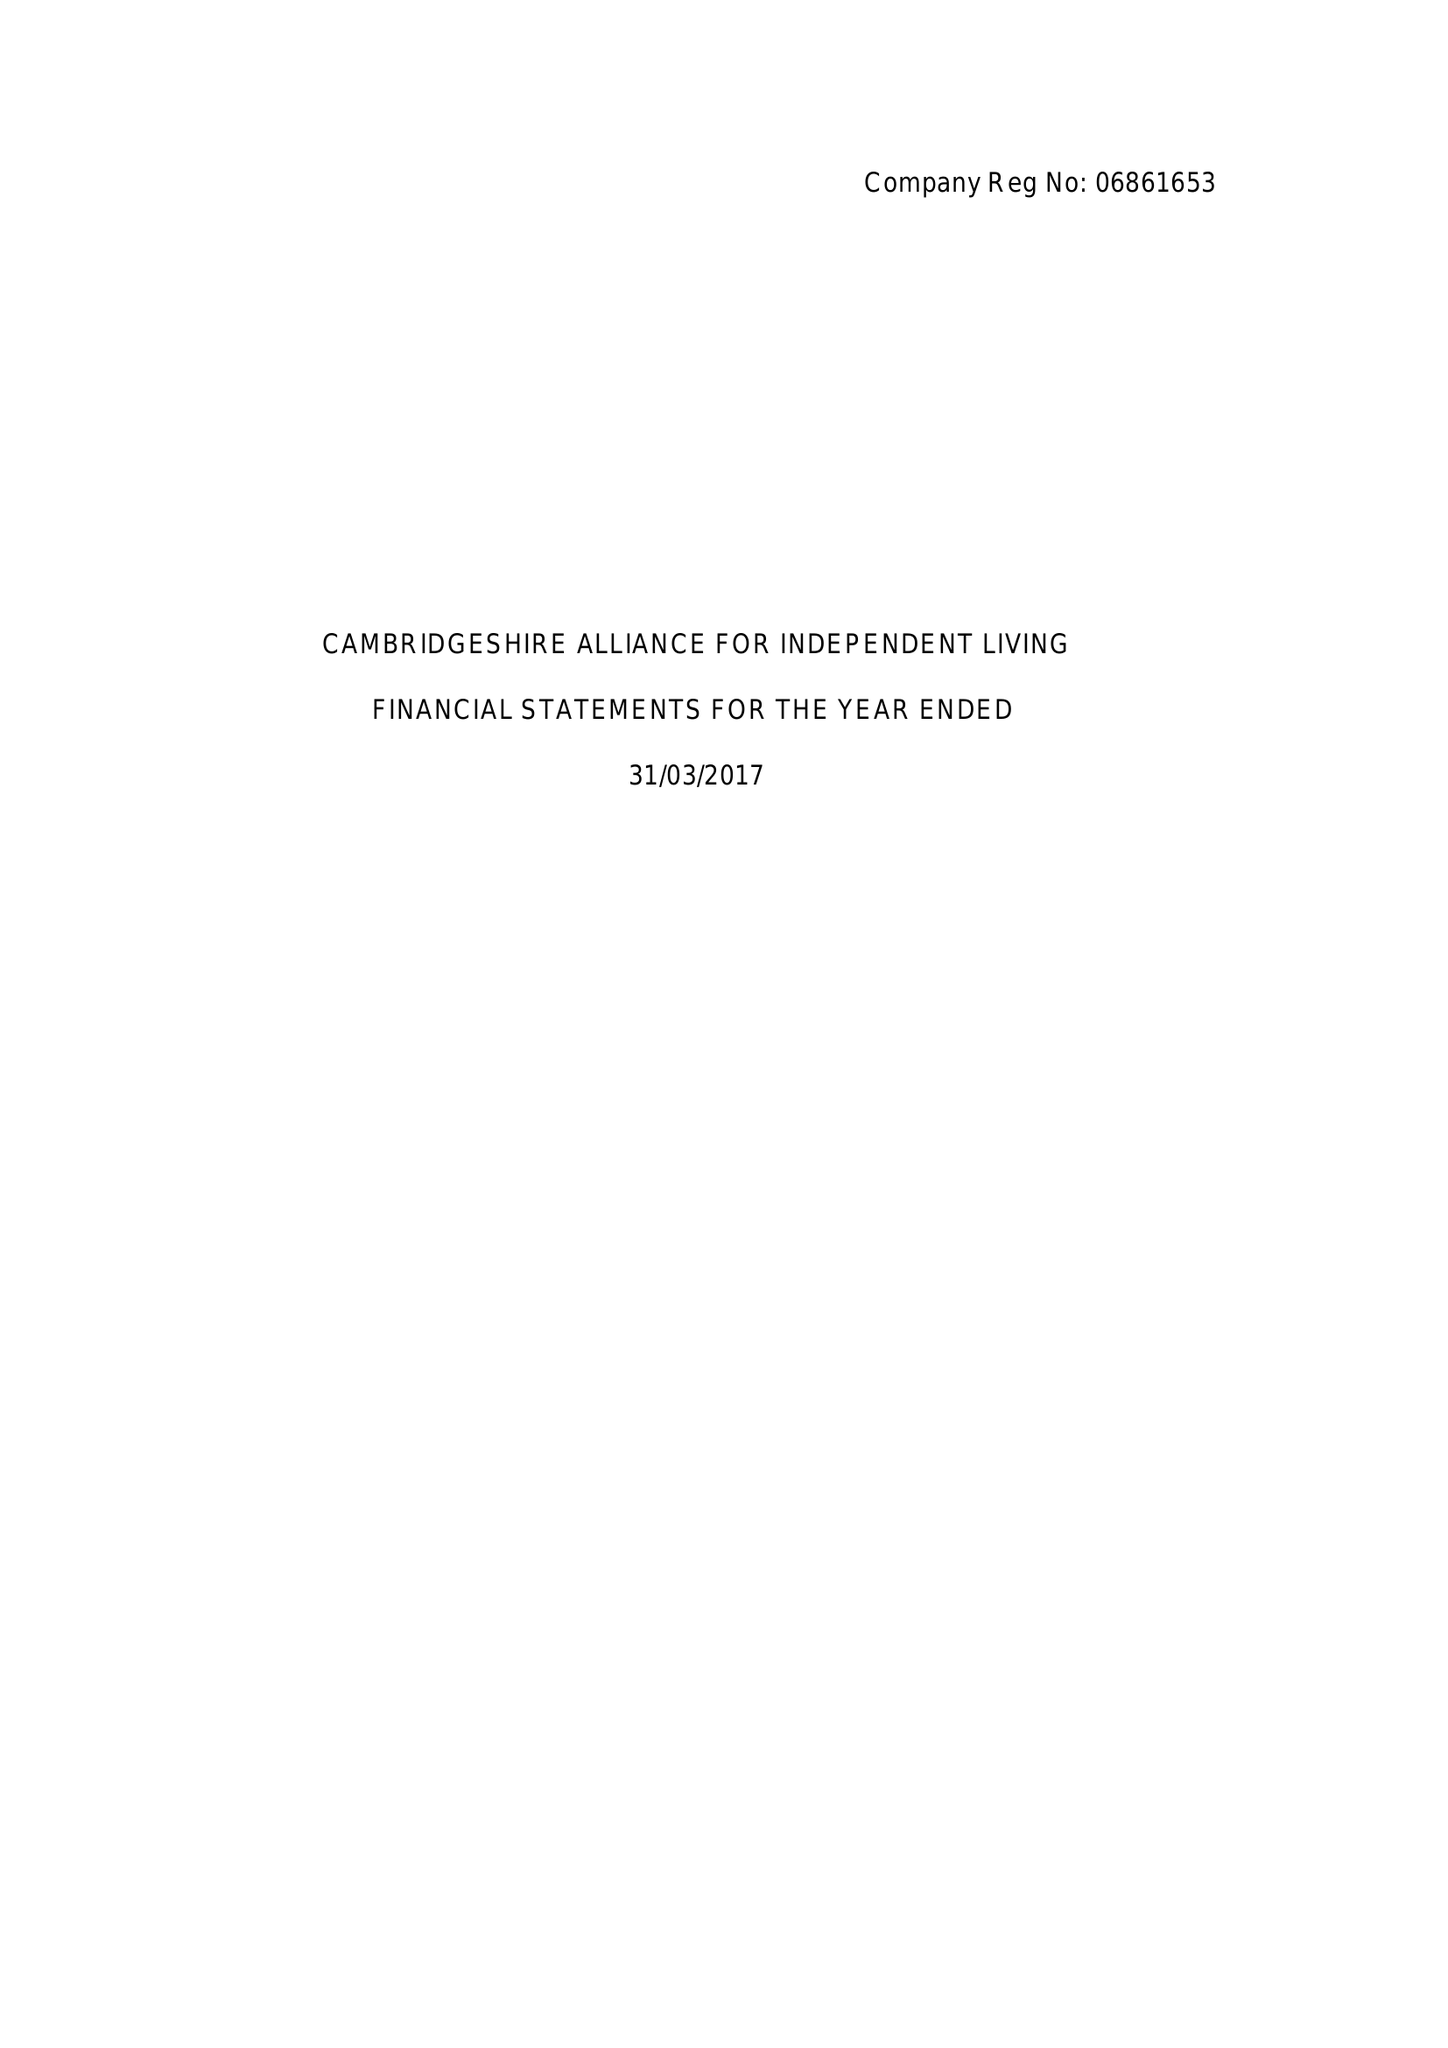What is the value for the charity_name?
Answer the question using a single word or phrase. Cambridgeshire Alliance For Independent Living. 